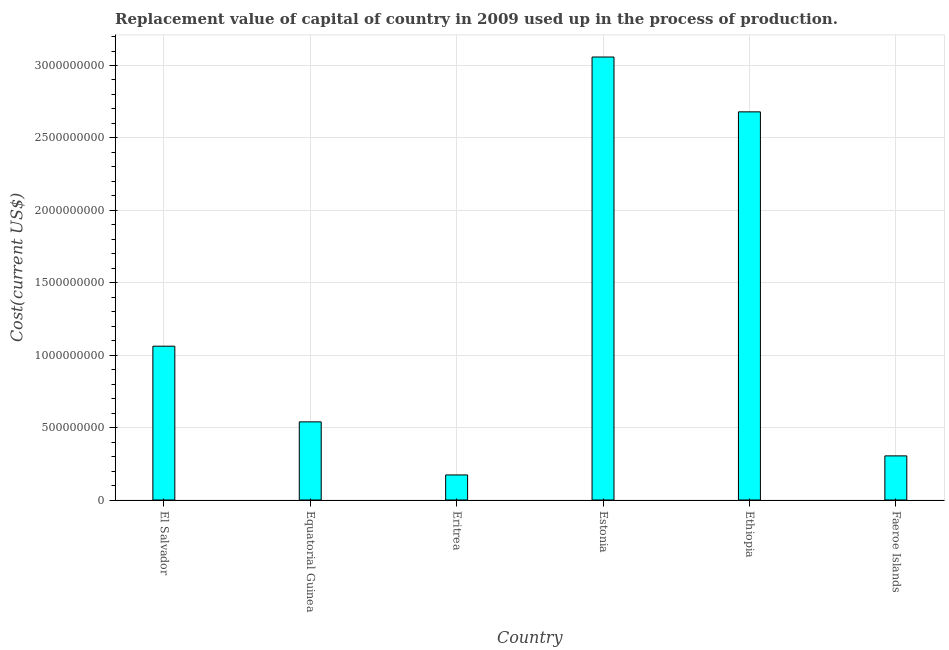What is the title of the graph?
Offer a very short reply. Replacement value of capital of country in 2009 used up in the process of production. What is the label or title of the X-axis?
Your answer should be compact. Country. What is the label or title of the Y-axis?
Provide a succinct answer. Cost(current US$). What is the consumption of fixed capital in Equatorial Guinea?
Keep it short and to the point. 5.39e+08. Across all countries, what is the maximum consumption of fixed capital?
Provide a short and direct response. 3.06e+09. Across all countries, what is the minimum consumption of fixed capital?
Keep it short and to the point. 1.73e+08. In which country was the consumption of fixed capital maximum?
Keep it short and to the point. Estonia. In which country was the consumption of fixed capital minimum?
Keep it short and to the point. Eritrea. What is the sum of the consumption of fixed capital?
Provide a short and direct response. 7.82e+09. What is the difference between the consumption of fixed capital in El Salvador and Estonia?
Keep it short and to the point. -2.00e+09. What is the average consumption of fixed capital per country?
Offer a terse response. 1.30e+09. What is the median consumption of fixed capital?
Offer a terse response. 8.01e+08. In how many countries, is the consumption of fixed capital greater than 1400000000 US$?
Make the answer very short. 2. What is the ratio of the consumption of fixed capital in El Salvador to that in Equatorial Guinea?
Your response must be concise. 1.97. Is the difference between the consumption of fixed capital in El Salvador and Equatorial Guinea greater than the difference between any two countries?
Your answer should be very brief. No. What is the difference between the highest and the second highest consumption of fixed capital?
Keep it short and to the point. 3.79e+08. Is the sum of the consumption of fixed capital in Equatorial Guinea and Eritrea greater than the maximum consumption of fixed capital across all countries?
Ensure brevity in your answer.  No. What is the difference between the highest and the lowest consumption of fixed capital?
Offer a terse response. 2.89e+09. In how many countries, is the consumption of fixed capital greater than the average consumption of fixed capital taken over all countries?
Offer a very short reply. 2. How many countries are there in the graph?
Keep it short and to the point. 6. Are the values on the major ticks of Y-axis written in scientific E-notation?
Give a very brief answer. No. What is the Cost(current US$) of El Salvador?
Your answer should be compact. 1.06e+09. What is the Cost(current US$) in Equatorial Guinea?
Provide a short and direct response. 5.39e+08. What is the Cost(current US$) in Eritrea?
Ensure brevity in your answer.  1.73e+08. What is the Cost(current US$) of Estonia?
Offer a terse response. 3.06e+09. What is the Cost(current US$) of Ethiopia?
Provide a succinct answer. 2.68e+09. What is the Cost(current US$) of Faeroe Islands?
Ensure brevity in your answer.  3.05e+08. What is the difference between the Cost(current US$) in El Salvador and Equatorial Guinea?
Your answer should be compact. 5.23e+08. What is the difference between the Cost(current US$) in El Salvador and Eritrea?
Provide a short and direct response. 8.89e+08. What is the difference between the Cost(current US$) in El Salvador and Estonia?
Offer a very short reply. -2.00e+09. What is the difference between the Cost(current US$) in El Salvador and Ethiopia?
Your answer should be very brief. -1.62e+09. What is the difference between the Cost(current US$) in El Salvador and Faeroe Islands?
Provide a succinct answer. 7.57e+08. What is the difference between the Cost(current US$) in Equatorial Guinea and Eritrea?
Your response must be concise. 3.66e+08. What is the difference between the Cost(current US$) in Equatorial Guinea and Estonia?
Offer a very short reply. -2.52e+09. What is the difference between the Cost(current US$) in Equatorial Guinea and Ethiopia?
Provide a succinct answer. -2.14e+09. What is the difference between the Cost(current US$) in Equatorial Guinea and Faeroe Islands?
Offer a very short reply. 2.35e+08. What is the difference between the Cost(current US$) in Eritrea and Estonia?
Your answer should be very brief. -2.89e+09. What is the difference between the Cost(current US$) in Eritrea and Ethiopia?
Offer a terse response. -2.51e+09. What is the difference between the Cost(current US$) in Eritrea and Faeroe Islands?
Your answer should be compact. -1.32e+08. What is the difference between the Cost(current US$) in Estonia and Ethiopia?
Your answer should be compact. 3.79e+08. What is the difference between the Cost(current US$) in Estonia and Faeroe Islands?
Give a very brief answer. 2.75e+09. What is the difference between the Cost(current US$) in Ethiopia and Faeroe Islands?
Your answer should be compact. 2.38e+09. What is the ratio of the Cost(current US$) in El Salvador to that in Equatorial Guinea?
Provide a short and direct response. 1.97. What is the ratio of the Cost(current US$) in El Salvador to that in Eritrea?
Keep it short and to the point. 6.14. What is the ratio of the Cost(current US$) in El Salvador to that in Estonia?
Ensure brevity in your answer.  0.35. What is the ratio of the Cost(current US$) in El Salvador to that in Ethiopia?
Provide a short and direct response. 0.4. What is the ratio of the Cost(current US$) in El Salvador to that in Faeroe Islands?
Keep it short and to the point. 3.49. What is the ratio of the Cost(current US$) in Equatorial Guinea to that in Eritrea?
Your answer should be very brief. 3.12. What is the ratio of the Cost(current US$) in Equatorial Guinea to that in Estonia?
Provide a short and direct response. 0.18. What is the ratio of the Cost(current US$) in Equatorial Guinea to that in Ethiopia?
Provide a short and direct response. 0.2. What is the ratio of the Cost(current US$) in Equatorial Guinea to that in Faeroe Islands?
Keep it short and to the point. 1.77. What is the ratio of the Cost(current US$) in Eritrea to that in Estonia?
Offer a terse response. 0.06. What is the ratio of the Cost(current US$) in Eritrea to that in Ethiopia?
Your response must be concise. 0.07. What is the ratio of the Cost(current US$) in Eritrea to that in Faeroe Islands?
Provide a succinct answer. 0.57. What is the ratio of the Cost(current US$) in Estonia to that in Ethiopia?
Your answer should be very brief. 1.14. What is the ratio of the Cost(current US$) in Estonia to that in Faeroe Islands?
Provide a short and direct response. 10.04. What is the ratio of the Cost(current US$) in Ethiopia to that in Faeroe Islands?
Make the answer very short. 8.8. 